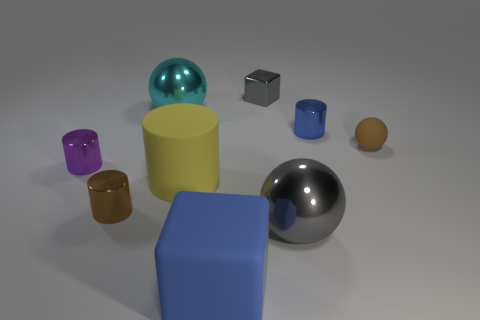Are there more blue cubes to the right of the matte cylinder than big cyan objects that are in front of the tiny purple thing?
Offer a terse response. Yes. There is a cyan metallic thing; does it have the same shape as the gray shiny thing that is left of the gray metallic sphere?
Provide a succinct answer. No. Is the size of the gray metal thing that is in front of the small cube the same as the blue thing that is behind the rubber cylinder?
Offer a terse response. No. Are there any big cyan objects that are left of the tiny metal thing right of the gray metal thing that is behind the tiny purple object?
Provide a short and direct response. Yes. Are there fewer blue cylinders that are to the right of the small brown matte ball than rubber things that are in front of the large yellow matte thing?
Provide a short and direct response. Yes. What is the shape of the blue object that is the same material as the big gray sphere?
Make the answer very short. Cylinder. What size is the sphere behind the brown object that is on the right side of the gray object behind the brown rubber object?
Your answer should be very brief. Large. Are there more gray matte spheres than yellow things?
Provide a succinct answer. No. Is the color of the shiny sphere that is in front of the tiny rubber object the same as the block behind the small purple metallic cylinder?
Offer a terse response. Yes. Do the cube that is left of the tiny gray metal thing and the blue thing right of the small block have the same material?
Keep it short and to the point. No. 